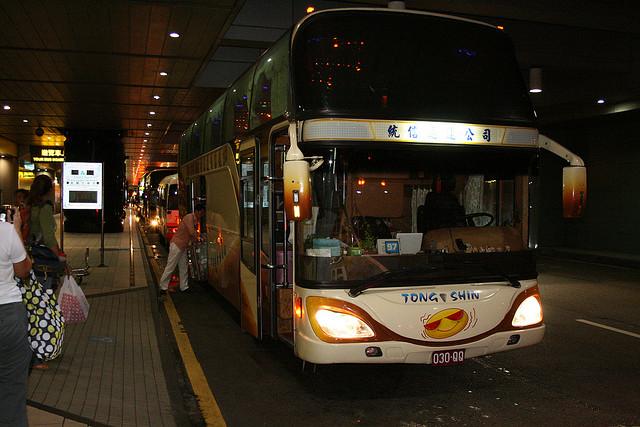What is parked on the street?
Keep it brief. Bus. What brand is the bus?
Be succinct. Tong shin. What design is on the front of the bus?
Keep it brief. Smiley face. What time was the pic taken?
Answer briefly. Night. Is it day time?
Answer briefly. No. 